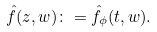<formula> <loc_0><loc_0><loc_500><loc_500>\hat { f } ( z , w ) \colon = \hat { f } _ { \phi } ( t , w ) .</formula> 